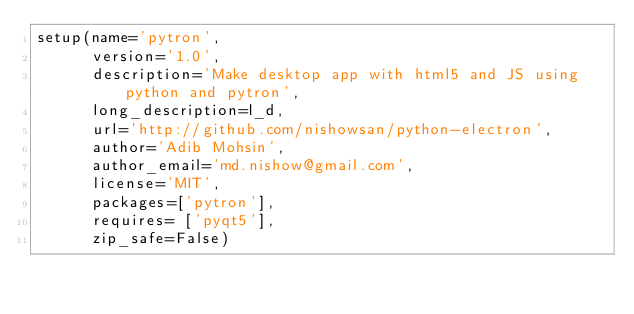<code> <loc_0><loc_0><loc_500><loc_500><_Python_>setup(name='pytron',
      version='1.0',
      description='Make desktop app with html5 and JS using python and pytron',
      long_description=l_d,
      url='http://github.com/nishowsan/python-electron',
      author='Adib Mohsin',
      author_email='md.nishow@gmail.com',
      license='MIT',
      packages=['pytron'],
      requires= ['pyqt5'],
      zip_safe=False)</code> 